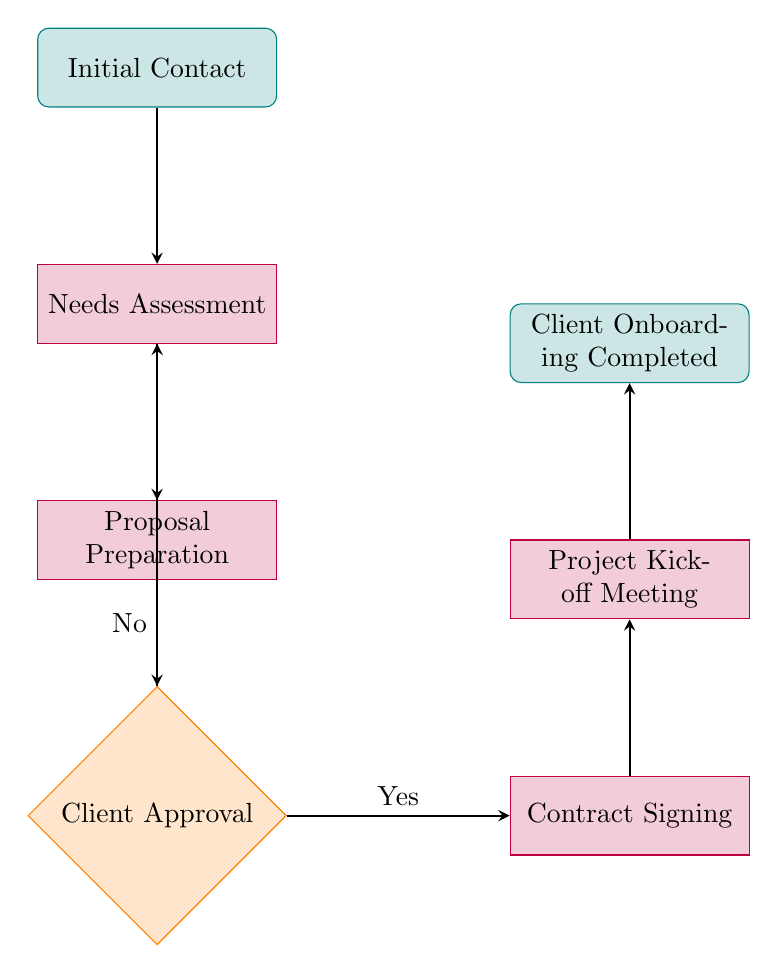What is the starting point of the onboarding process? The first node in the flow chart is "Initial Contact," indicating where the onboarding process begins.
Answer: Initial Contact How many nodes are there in the diagram? By counting the different process steps and decision points in the flow chart, there are a total of 7 nodes.
Answer: 7 What follows after "Proposal Preparation"? The flow chart shows that the next step after "Proposal Preparation" is "Client Approval."
Answer: Client Approval If the client does not approve the proposal, what is the next step? According to the diagram, if the client does not approve the proposal, the process returns to "Needs Assessment."
Answer: Needs Assessment What is the final step in the onboarding process? The last node in the flow chart is "Client Onboarding Completed," indicating the conclusion of the process.
Answer: Client Onboarding Completed Which node directly leads to "Contract Signing"? The arrow from "Client Approval" (when approved) points directly to "Contract Signing," indicating the direct connection between these two nodes.
Answer: Contract Signing What happens after the "Contract Signing" step? The next action after "Contract Signing" is "Project Kickoff Meeting," as indicated by the flow chart's connections.
Answer: Project Kickoff Meeting What is the type of the node "Client Approval"? The "Client Approval" node is classified as a decision, representing a point where a choice must be made.
Answer: decision 